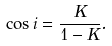<formula> <loc_0><loc_0><loc_500><loc_500>\cos i = \frac { K } { 1 - K } .</formula> 